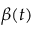Convert formula to latex. <formula><loc_0><loc_0><loc_500><loc_500>\beta ( t )</formula> 